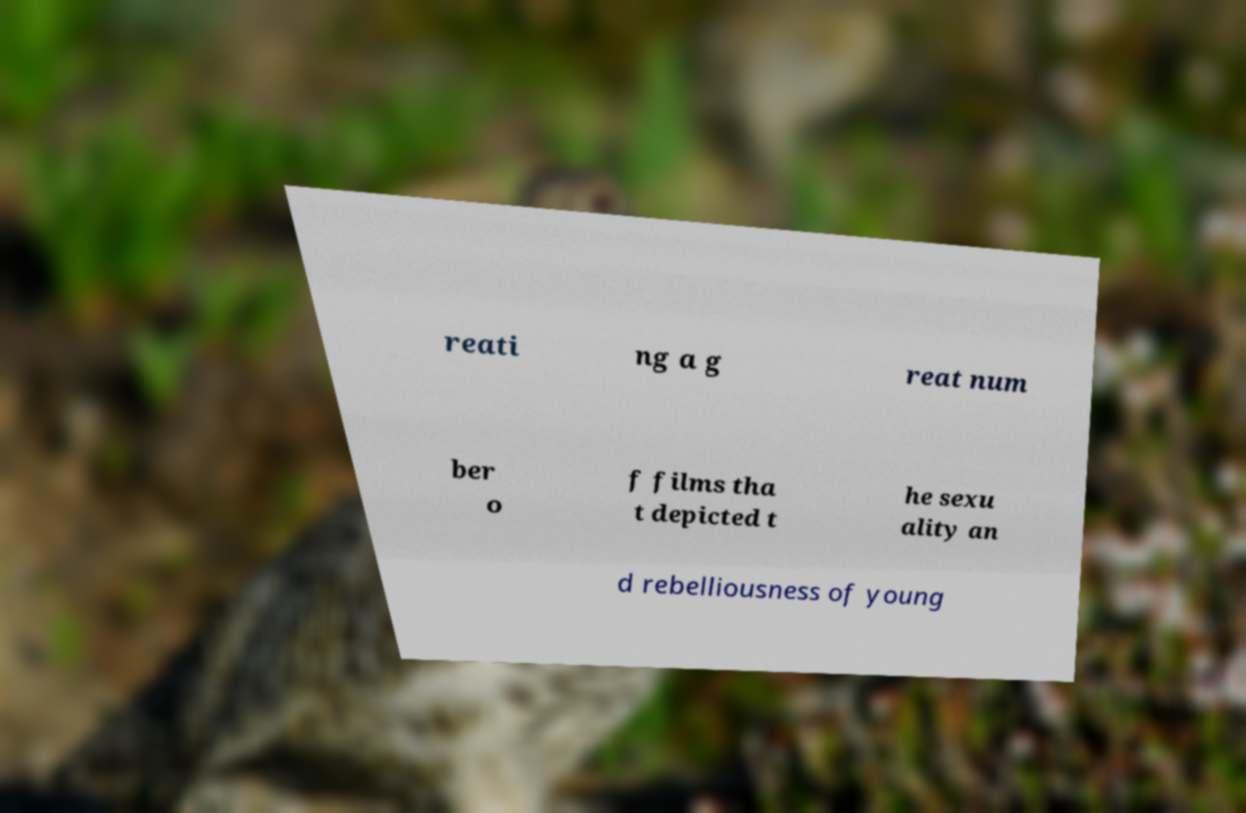Please read and relay the text visible in this image. What does it say? reati ng a g reat num ber o f films tha t depicted t he sexu ality an d rebelliousness of young 